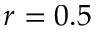Convert formula to latex. <formula><loc_0><loc_0><loc_500><loc_500>r = 0 . 5</formula> 